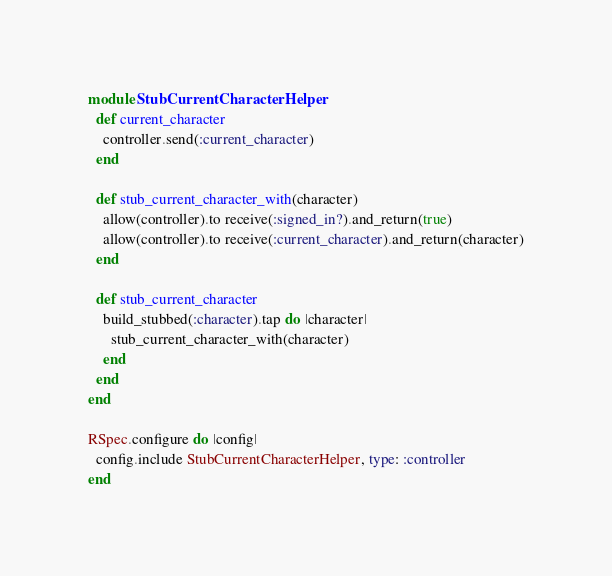Convert code to text. <code><loc_0><loc_0><loc_500><loc_500><_Ruby_>module StubCurrentCharacterHelper
  def current_character
    controller.send(:current_character)
  end

  def stub_current_character_with(character)
    allow(controller).to receive(:signed_in?).and_return(true)
    allow(controller).to receive(:current_character).and_return(character)
  end

  def stub_current_character
    build_stubbed(:character).tap do |character|
      stub_current_character_with(character)
    end
  end
end

RSpec.configure do |config|
  config.include StubCurrentCharacterHelper, type: :controller
end
</code> 